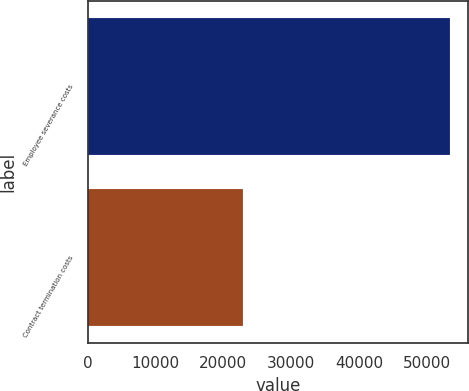Convert chart. <chart><loc_0><loc_0><loc_500><loc_500><bar_chart><fcel>Employee severance costs<fcel>Contract termination costs<nl><fcel>53463<fcel>22925<nl></chart> 